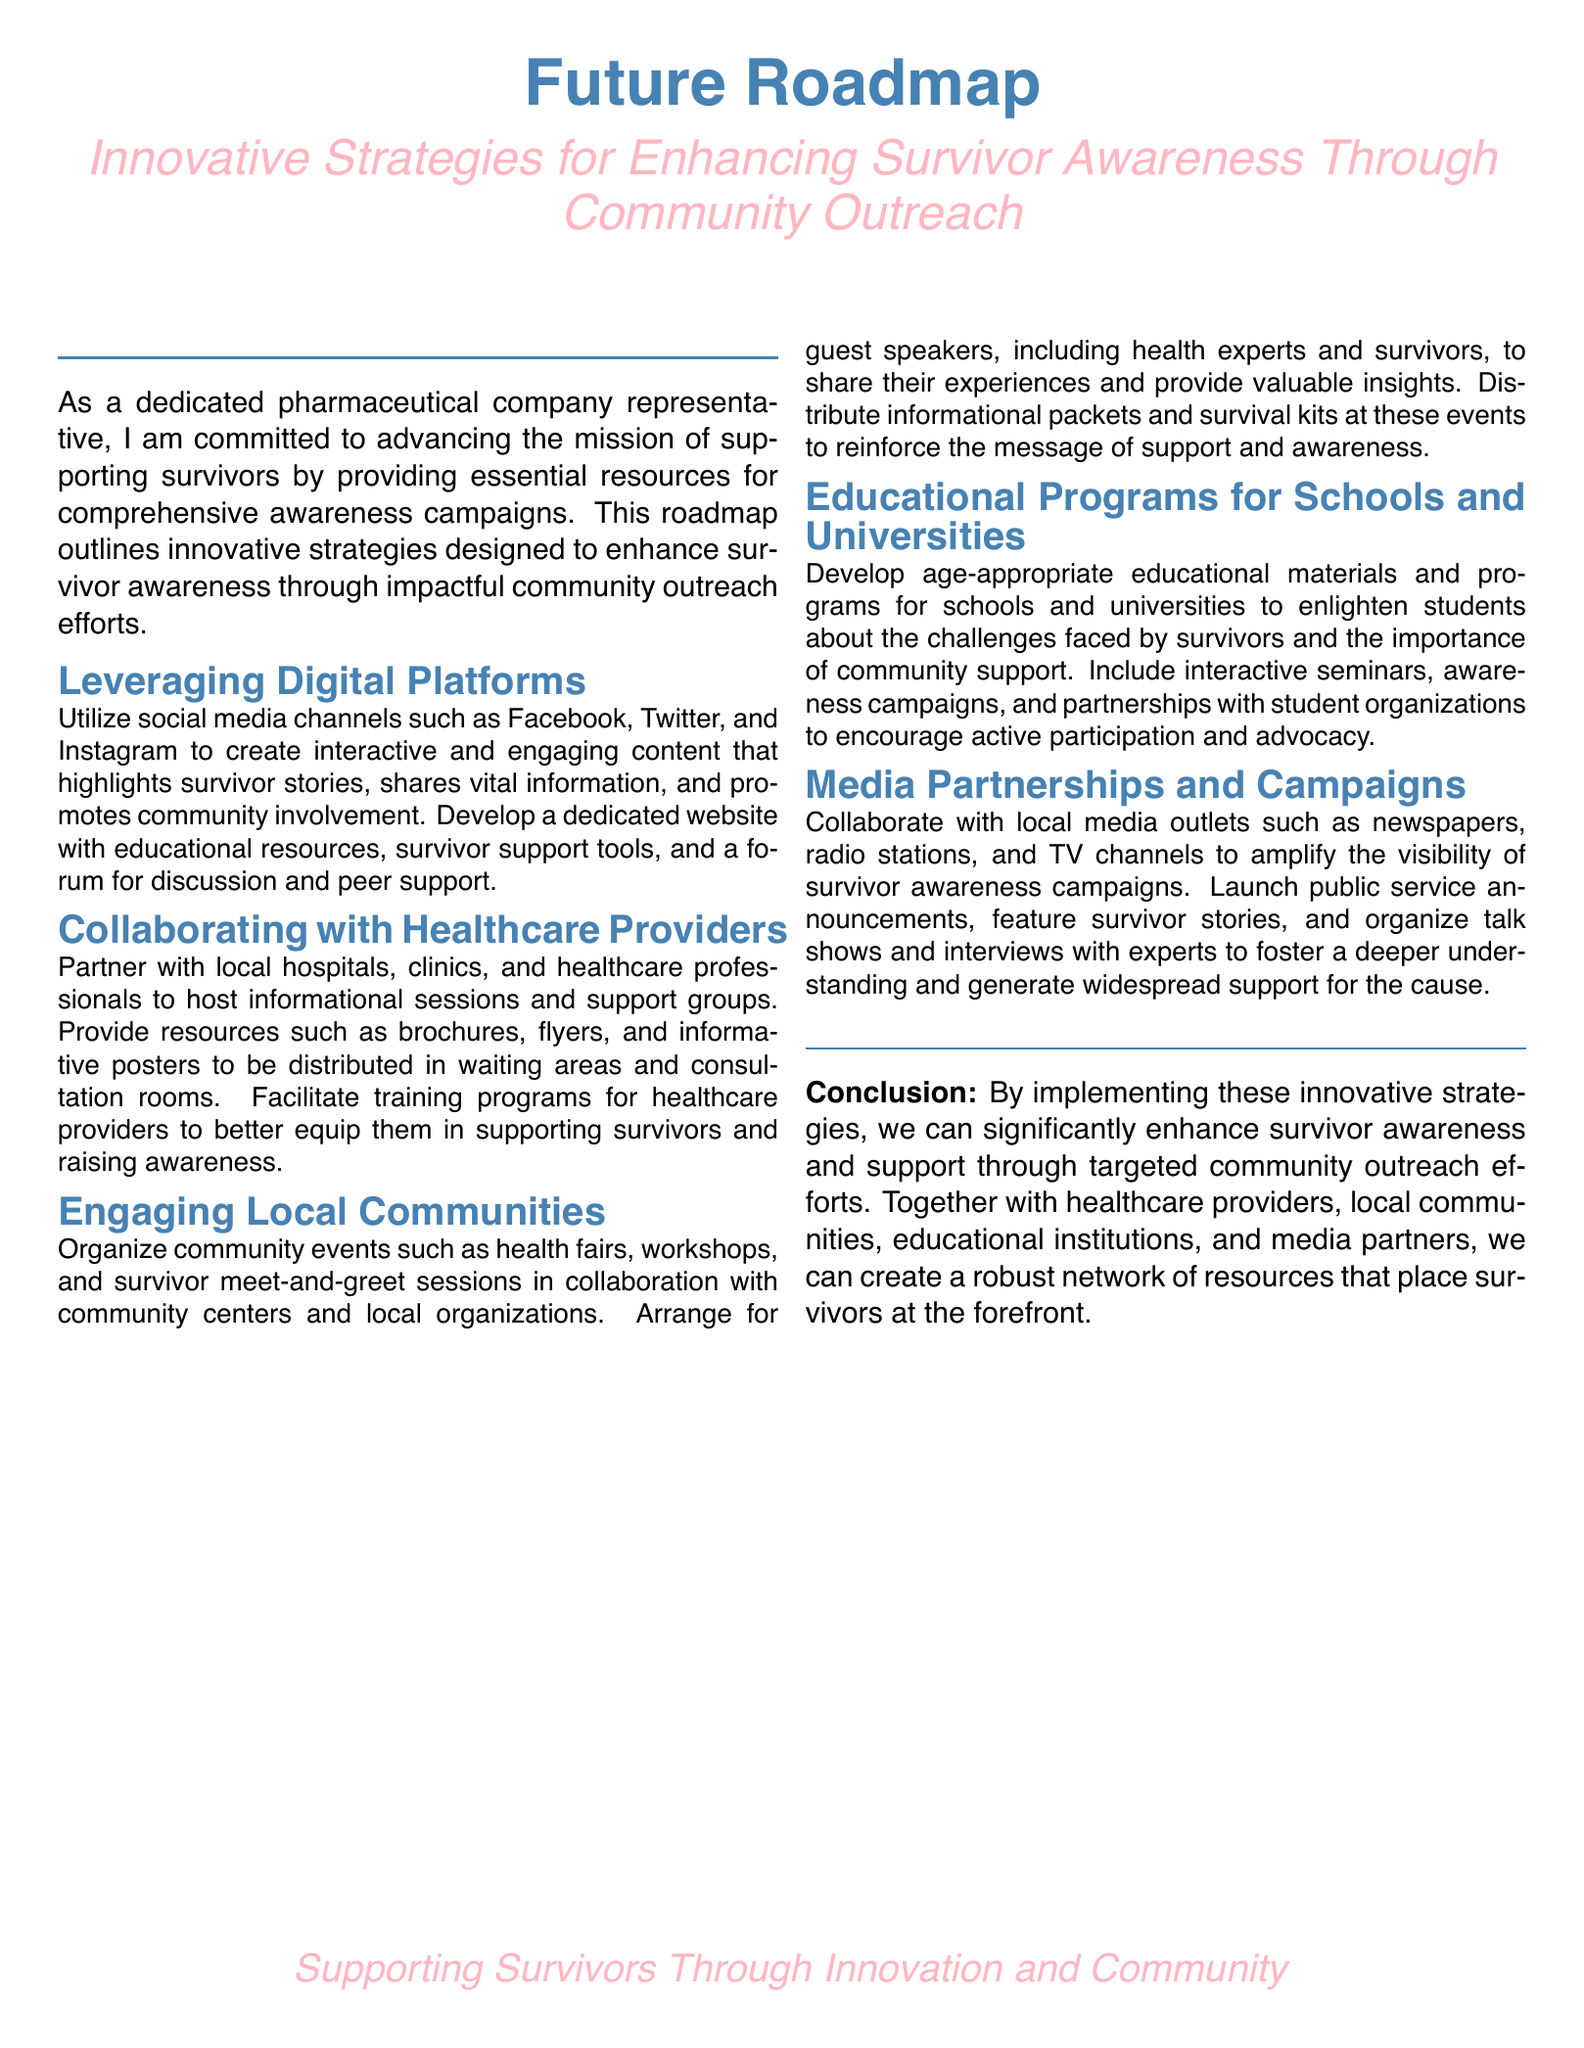What is the title of the document? The title of the document is prominently displayed at the beginning, indicating the subject of the roadmap.
Answer: Future Roadmap What are the two primary colors used in the document? The document uses two main colors, which are highlighted in various sections.
Answer: medicalpink and medicalblue How many sections are outlined in the roadmap? The document clearly lists distinct strategies within separate sections for reader clarity.
Answer: Five What type of programs does the roadmap propose for educational institutions? The document specifies the nature of programs aimed at enlightening students, reflecting its community outreach approach.
Answer: Educational programs Which digital platforms are suggested for enhancing survivor awareness? Specific platforms are mentioned in the section on leveraging digital technologies for awareness campaigns.
Answer: Facebook, Twitter, and Instagram Who should healthcare providers collaborate with, according to the document? The document advises partnerships for hosting sessions and support, emphasizing the importance of collaboration.
Answer: Local hospitals and clinics What type of community events does the roadmap suggest organizing? The document mentions specific types of gatherings aimed at raising awareness within the community.
Answer: Health fairs Is there a conclusion in the document? The document features a section summarizing the overall intent and potential impact of the proposed strategies.
Answer: Yes What is the secondary focus of the document beyond survivor awareness? The document indicates another overarching goal tied to the strategies outlined for community involvement and outreach.
Answer: Innovation and community 